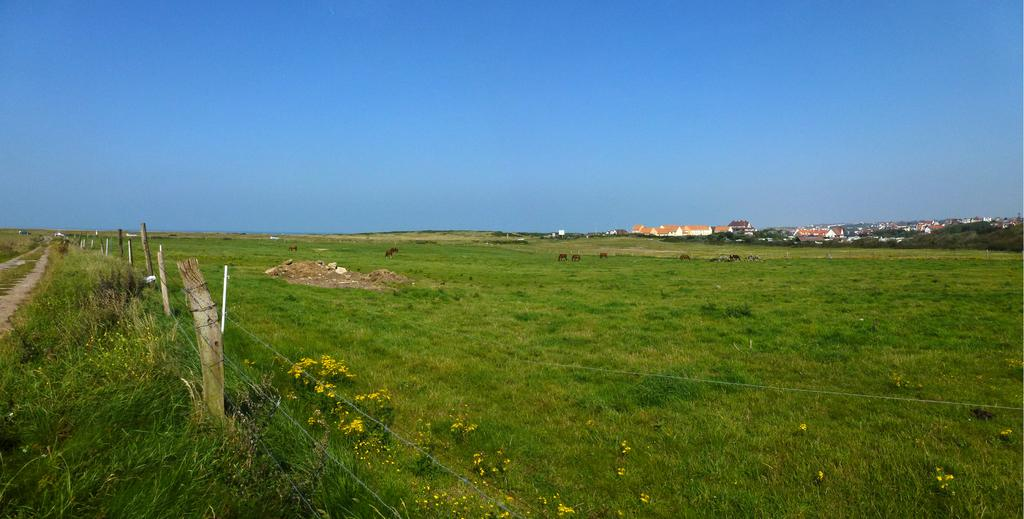What type of vegetation can be seen in the image? There is grass and flowers in the image. What type of structure is present in the image? There is a fence and buildings in the image. What type of natural elements can be seen in the image? There are stones, trees, and the sky visible in the image. What type of living organisms can be seen in the image? There are animals in the image. Where is the lettuce growing in the image? There is no lettuce present in the image. What type of wheel can be seen in the image? There is no wheel present in the image. 